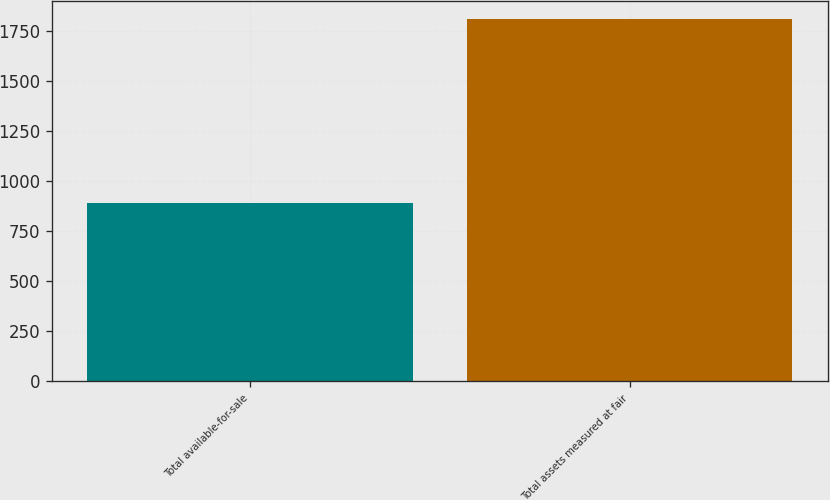Convert chart. <chart><loc_0><loc_0><loc_500><loc_500><bar_chart><fcel>Total available-for-sale<fcel>Total assets measured at fair<nl><fcel>893<fcel>1810<nl></chart> 